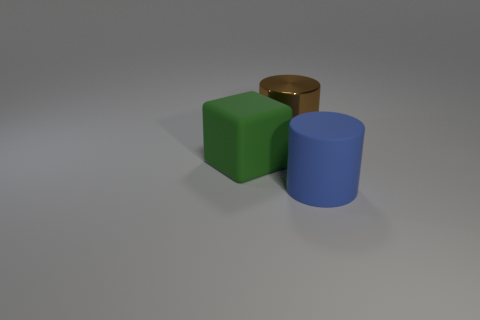Add 2 big shiny cylinders. How many objects exist? 5 Subtract all cylinders. How many objects are left? 1 Add 3 large blue rubber cylinders. How many large blue rubber cylinders are left? 4 Add 3 big green cubes. How many big green cubes exist? 4 Subtract 0 cyan blocks. How many objects are left? 3 Subtract all big gray metal balls. Subtract all blue rubber cylinders. How many objects are left? 2 